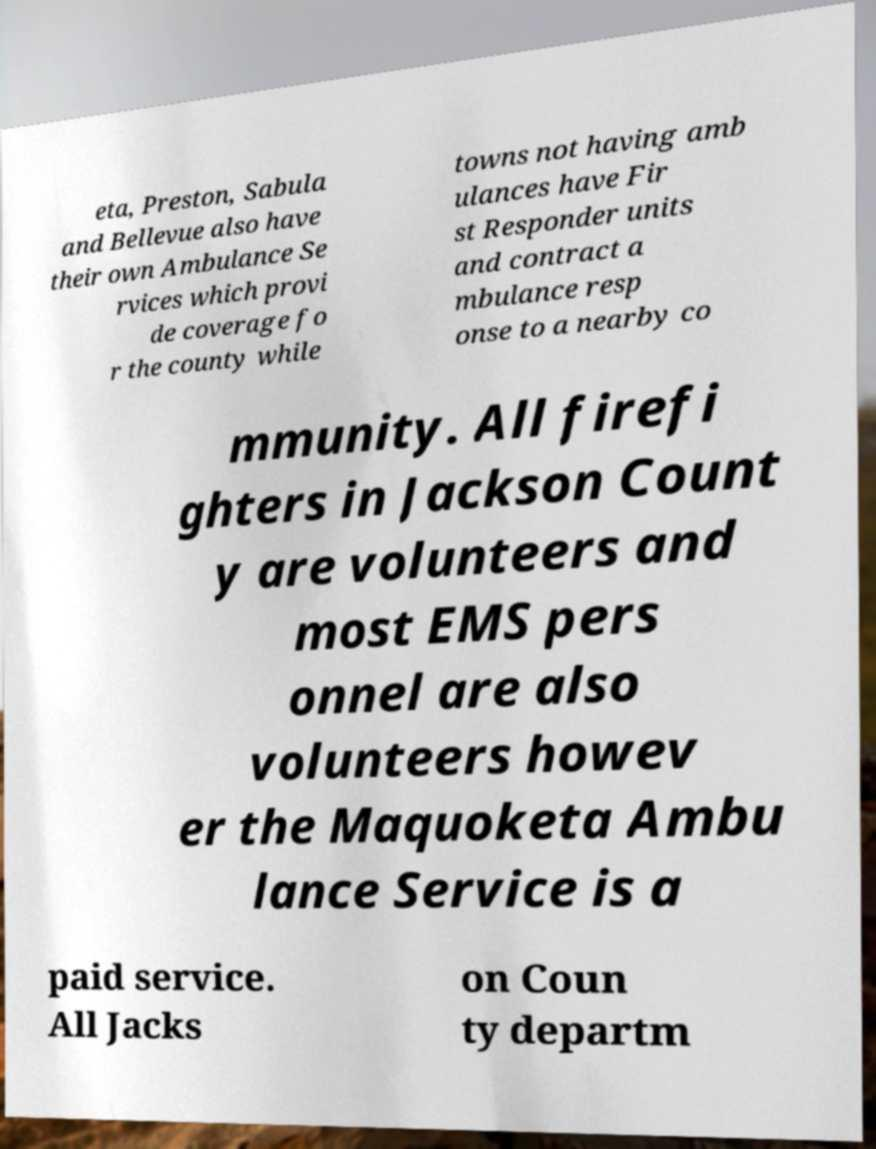I need the written content from this picture converted into text. Can you do that? eta, Preston, Sabula and Bellevue also have their own Ambulance Se rvices which provi de coverage fo r the county while towns not having amb ulances have Fir st Responder units and contract a mbulance resp onse to a nearby co mmunity. All firefi ghters in Jackson Count y are volunteers and most EMS pers onnel are also volunteers howev er the Maquoketa Ambu lance Service is a paid service. All Jacks on Coun ty departm 